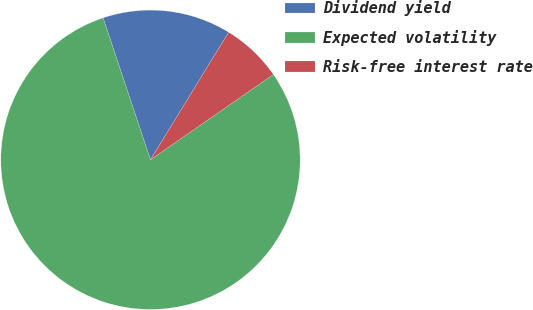Convert chart. <chart><loc_0><loc_0><loc_500><loc_500><pie_chart><fcel>Dividend yield<fcel>Expected volatility<fcel>Risk-free interest rate<nl><fcel>13.88%<fcel>79.53%<fcel>6.59%<nl></chart> 